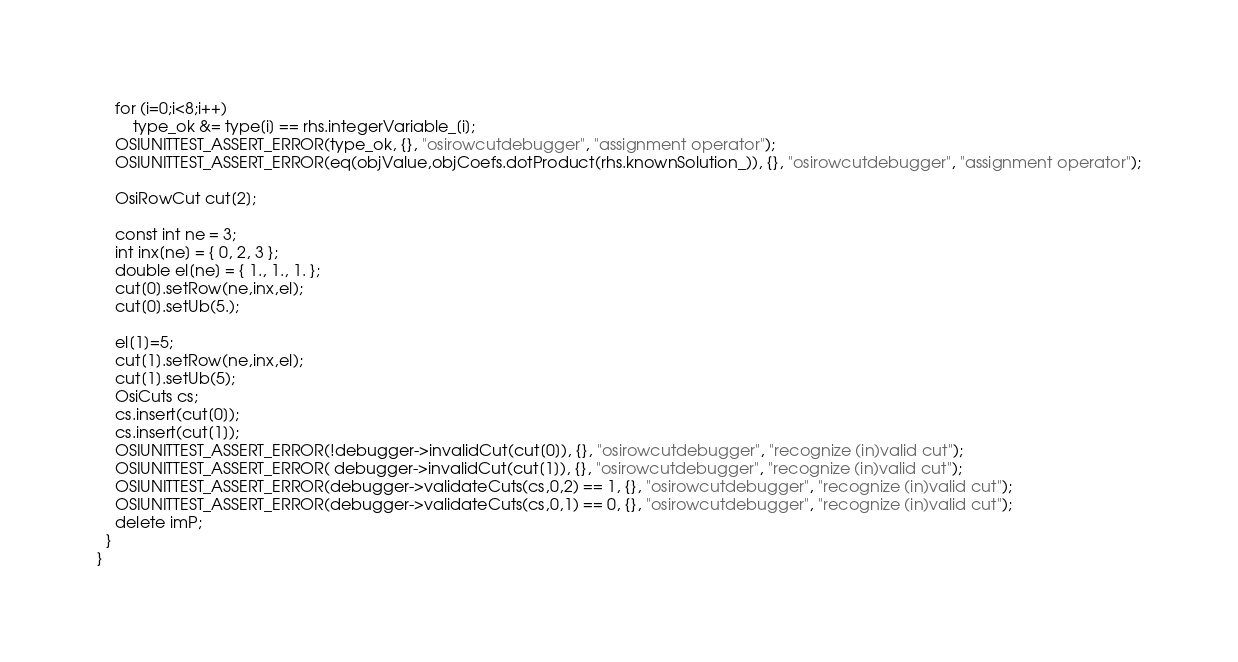Convert code to text. <code><loc_0><loc_0><loc_500><loc_500><_C++_>    for (i=0;i<8;i++)
    	type_ok &= type[i] == rhs.integerVariable_[i];
    OSIUNITTEST_ASSERT_ERROR(type_ok, {}, "osirowcutdebugger", "assignment operator");
    OSIUNITTEST_ASSERT_ERROR(eq(objValue,objCoefs.dotProduct(rhs.knownSolution_)), {}, "osirowcutdebugger", "assignment operator");

    OsiRowCut cut[2];
    
    const int ne = 3;
    int inx[ne] = { 0, 2, 3 };
    double el[ne] = { 1., 1., 1. };
    cut[0].setRow(ne,inx,el);
    cut[0].setUb(5.);
    
    el[1]=5;
    cut[1].setRow(ne,inx,el);
    cut[1].setUb(5);
    OsiCuts cs; 
    cs.insert(cut[0]);
    cs.insert(cut[1]);
    OSIUNITTEST_ASSERT_ERROR(!debugger->invalidCut(cut[0]), {}, "osirowcutdebugger", "recognize (in)valid cut");
    OSIUNITTEST_ASSERT_ERROR( debugger->invalidCut(cut[1]), {}, "osirowcutdebugger", "recognize (in)valid cut");
    OSIUNITTEST_ASSERT_ERROR(debugger->validateCuts(cs,0,2) == 1, {}, "osirowcutdebugger", "recognize (in)valid cut");
    OSIUNITTEST_ASSERT_ERROR(debugger->validateCuts(cs,0,1) == 0, {}, "osirowcutdebugger", "recognize (in)valid cut");
    delete imP;
  }
}
</code> 